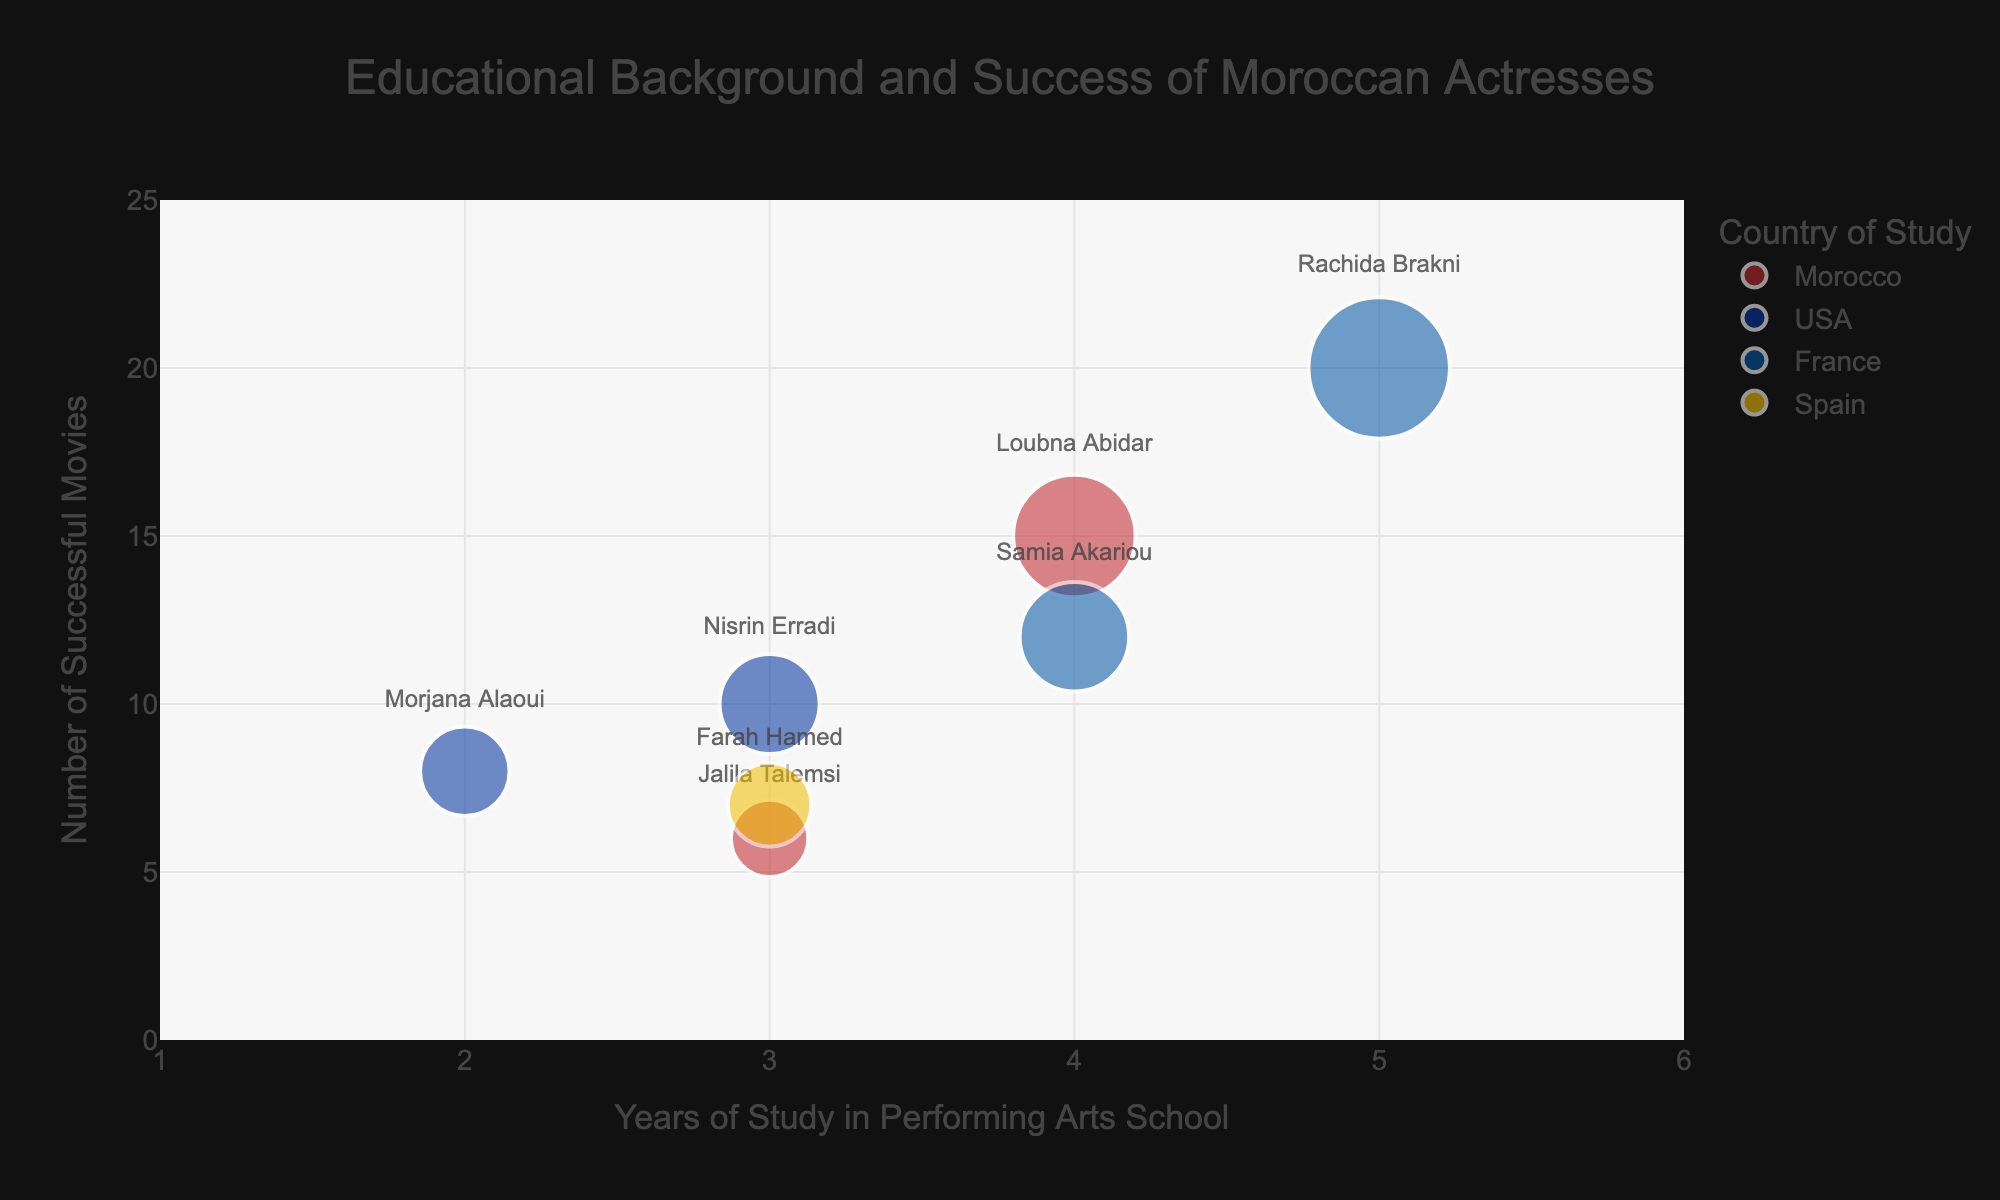What is the title of the figure? The title is usually displayed at the top of the figure. In this case, the title is 'Educational Background and Success of Moroccan Actresses'.
Answer: Educational Background and Success of Moroccan Actresses How many actresses studied in Morocco? Look at the colors representing countries. Morocco is shown in red, with two data points for Loubna Abidar and Jalila Talemsi.
Answer: 2 Which country has the most actresses represented? Count how many data points there are for each country. France has two data points for Rachida Brakni and Samia Akariou, and the other countries have either one or two. Additionally, based on the size and visible points, Morocco and France are compared, implying a possible tie but revealing more about successful representations in analysis.
Answer: Tied between Morocco and France Which actress has the most successful movies? Examine the y-axis where higher values represent a greater number of successful movies. Rachida Brakni, associated with France, has the highest value at 20 successful movies.
Answer: Rachida Brakni What is the unique color used to represent Spain? The color representing Spain is identified by looking for the actress who studied there and observing the color associated with her bubble. Farah Hamed is the only one who studied in Spain, represented by a yellow bubble.
Answer: Yellow On average, how many years did the actresses study in performing arts schools? Sum the years of study for each actress and divide by the total number of actresses. (4+3+5+4+2+3+3) / 7 = 24 / 7 ≈ 3.43
Answer: Approximately 3.43 Which actress studied for the shortest amount of time in a performing arts school? Refer to the x-axis where the years of study are marked. Morjana Alaoui studied for the least amount of time, which is 2 years.
Answer: Morjana Alaoui Who studied in the USA and how many successful movies did each have? Identify the bubbles representing the USA (blue color). Nisrin Erradi has 10 successful movies, and Morjana Alaoui has 8 successful movies.
Answer: Nisrin Erradi and Morjana Alaoui; 10 and 8 movies respectively How does the number of successful movies compare between those who studied in the USA and those in France? Add the successful movies for both the USA and France. USA: 10 (Nisrin Erradi) + 8 (Morjana Alaoui) = 18. France: 20 (Rachida Brakni) + 12 (Samia Akariou) = 32.
Answer: France: 32, USA: 18 How many actresses studied for 4 years? Locate circles on the x-axis at the 4-year mark. Loubna Abidar and Samia Akariou both studied for exactly 4 years.
Answer: 2 